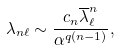<formula> <loc_0><loc_0><loc_500><loc_500>\lambda _ { n \ell } \sim \frac { c _ { n } \overline { \lambda } _ { \ell } ^ { n } } { \alpha ^ { q ( n - 1 ) } } ,</formula> 